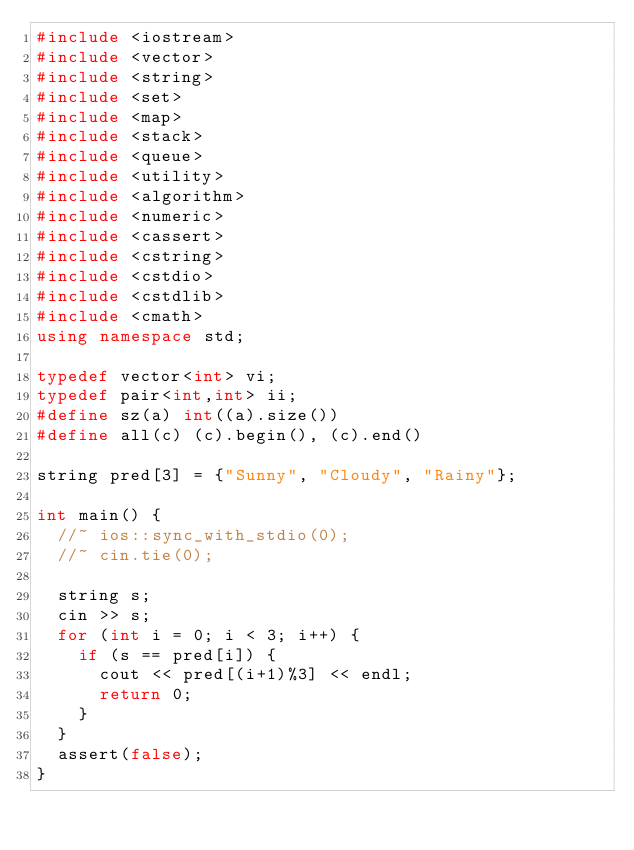<code> <loc_0><loc_0><loc_500><loc_500><_C++_>#include <iostream>
#include <vector>
#include <string>
#include <set>
#include <map>
#include <stack>
#include <queue>
#include <utility>
#include <algorithm>
#include <numeric>
#include <cassert>
#include <cstring>
#include <cstdio>
#include <cstdlib>
#include <cmath>
using namespace std;

typedef vector<int> vi;
typedef pair<int,int> ii;
#define sz(a) int((a).size())
#define all(c) (c).begin(), (c).end()

string pred[3] = {"Sunny", "Cloudy", "Rainy"};

int main() {
	//~ ios::sync_with_stdio(0);
	//~ cin.tie(0);

	string s;
	cin >> s;
	for (int i = 0; i < 3; i++) {
		if (s == pred[i]) {
			cout << pred[(i+1)%3] << endl;
			return 0;
		}
	}
	assert(false);
}
</code> 